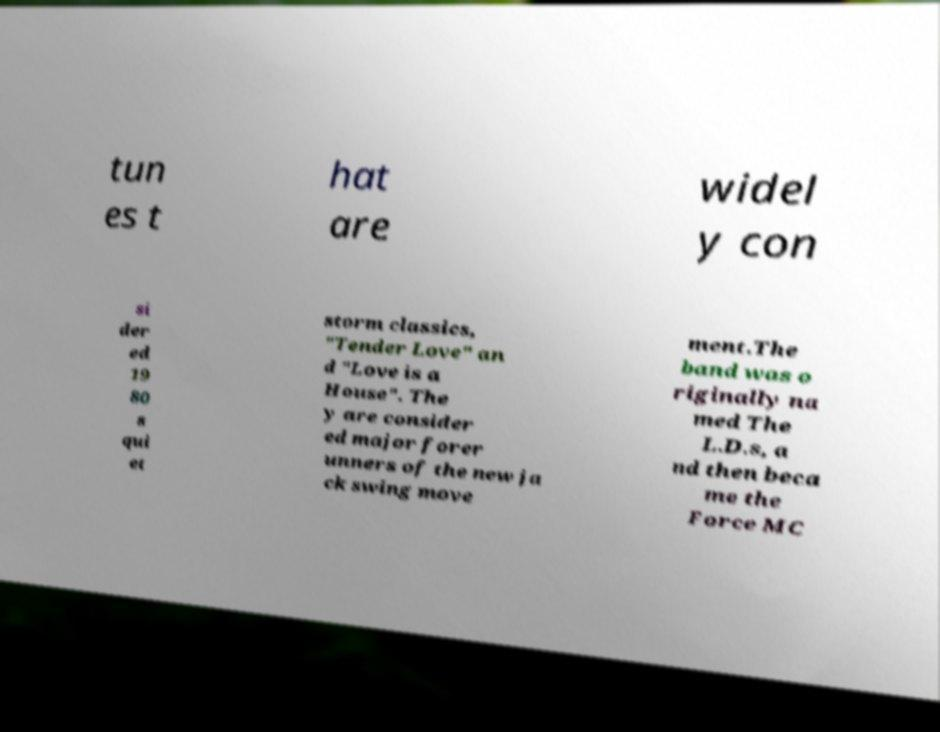For documentation purposes, I need the text within this image transcribed. Could you provide that? tun es t hat are widel y con si der ed 19 80 s qui et storm classics, "Tender Love" an d "Love is a House". The y are consider ed major forer unners of the new ja ck swing move ment.The band was o riginally na med The L.D.s, a nd then beca me the Force MC 